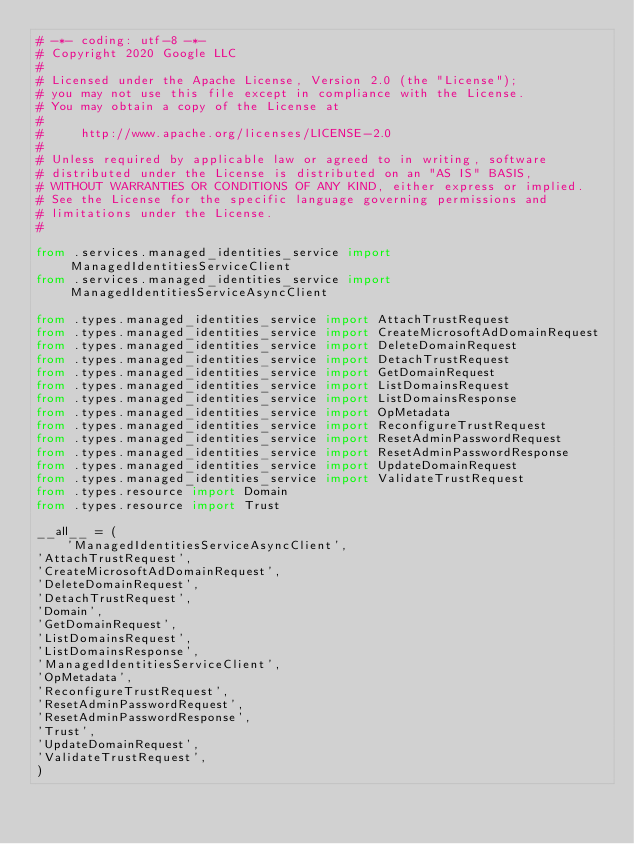Convert code to text. <code><loc_0><loc_0><loc_500><loc_500><_Python_># -*- coding: utf-8 -*-
# Copyright 2020 Google LLC
#
# Licensed under the Apache License, Version 2.0 (the "License");
# you may not use this file except in compliance with the License.
# You may obtain a copy of the License at
#
#     http://www.apache.org/licenses/LICENSE-2.0
#
# Unless required by applicable law or agreed to in writing, software
# distributed under the License is distributed on an "AS IS" BASIS,
# WITHOUT WARRANTIES OR CONDITIONS OF ANY KIND, either express or implied.
# See the License for the specific language governing permissions and
# limitations under the License.
#

from .services.managed_identities_service import ManagedIdentitiesServiceClient
from .services.managed_identities_service import ManagedIdentitiesServiceAsyncClient

from .types.managed_identities_service import AttachTrustRequest
from .types.managed_identities_service import CreateMicrosoftAdDomainRequest
from .types.managed_identities_service import DeleteDomainRequest
from .types.managed_identities_service import DetachTrustRequest
from .types.managed_identities_service import GetDomainRequest
from .types.managed_identities_service import ListDomainsRequest
from .types.managed_identities_service import ListDomainsResponse
from .types.managed_identities_service import OpMetadata
from .types.managed_identities_service import ReconfigureTrustRequest
from .types.managed_identities_service import ResetAdminPasswordRequest
from .types.managed_identities_service import ResetAdminPasswordResponse
from .types.managed_identities_service import UpdateDomainRequest
from .types.managed_identities_service import ValidateTrustRequest
from .types.resource import Domain
from .types.resource import Trust

__all__ = (
    'ManagedIdentitiesServiceAsyncClient',
'AttachTrustRequest',
'CreateMicrosoftAdDomainRequest',
'DeleteDomainRequest',
'DetachTrustRequest',
'Domain',
'GetDomainRequest',
'ListDomainsRequest',
'ListDomainsResponse',
'ManagedIdentitiesServiceClient',
'OpMetadata',
'ReconfigureTrustRequest',
'ResetAdminPasswordRequest',
'ResetAdminPasswordResponse',
'Trust',
'UpdateDomainRequest',
'ValidateTrustRequest',
)
</code> 